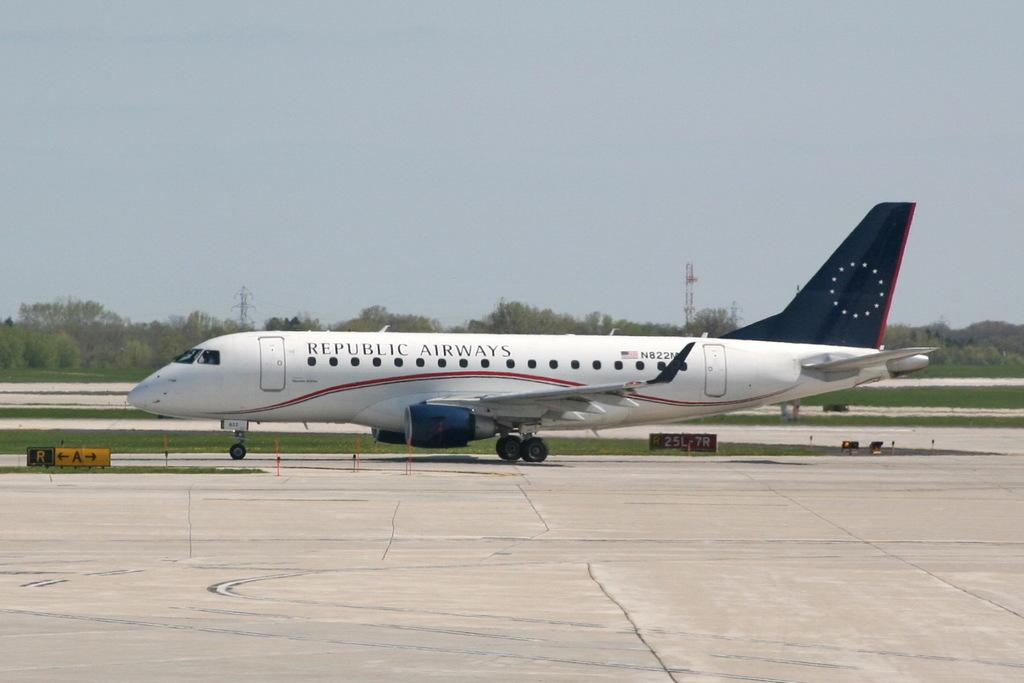<image>
Share a concise interpretation of the image provided. A Republic airways airplane on the runway outside 